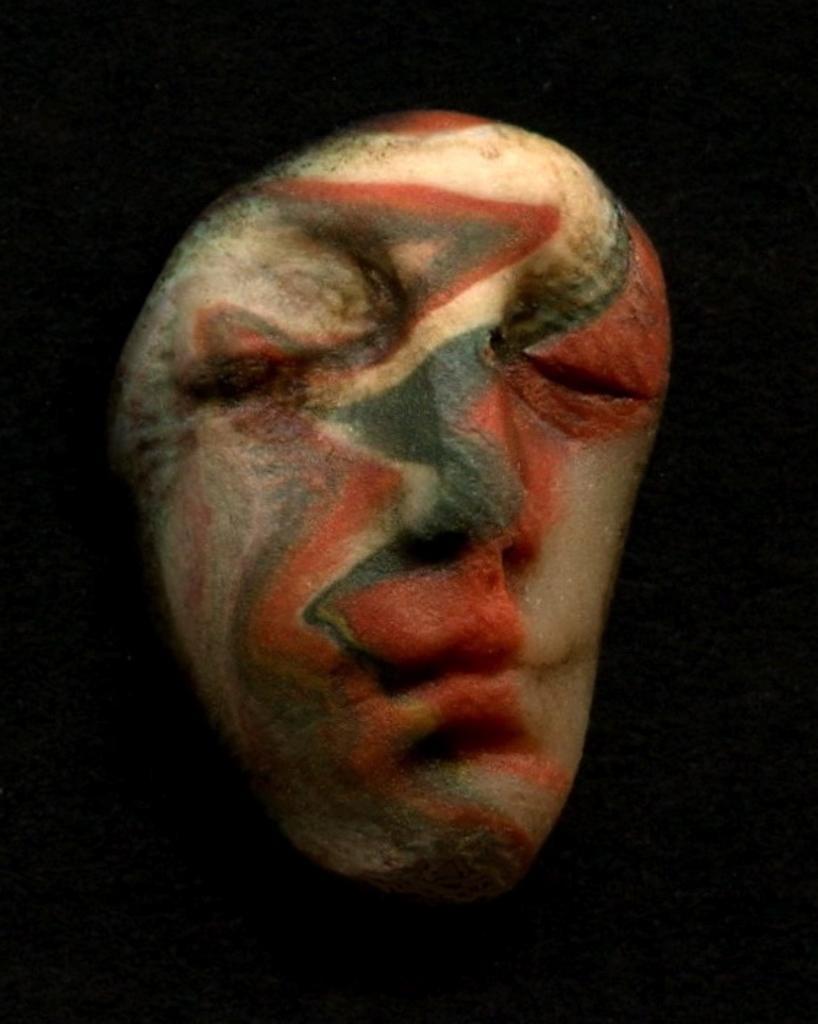Could you give a brief overview of what you see in this image? In this image it looks like a tattoo of a person's face and dark background. 